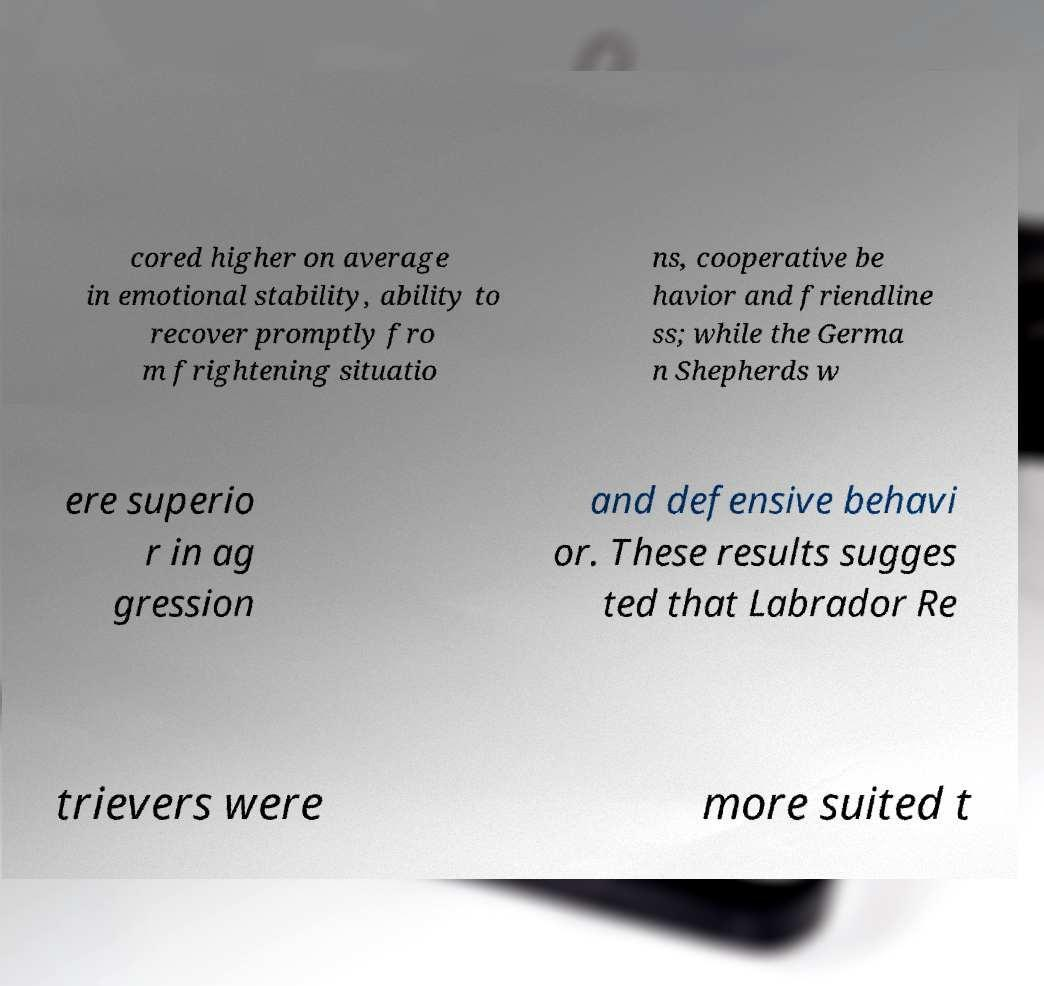Could you assist in decoding the text presented in this image and type it out clearly? cored higher on average in emotional stability, ability to recover promptly fro m frightening situatio ns, cooperative be havior and friendline ss; while the Germa n Shepherds w ere superio r in ag gression and defensive behavi or. These results sugges ted that Labrador Re trievers were more suited t 